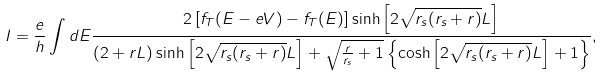<formula> <loc_0><loc_0><loc_500><loc_500>I = \frac { e } { h } \int d E \frac { 2 \left [ f _ { T } ( E - e V ) - f _ { T } ( E ) \right ] \sinh { \left [ 2 \sqrt { r _ { s } ( r _ { s } + r ) } L \right ] } } { ( 2 + r L ) \sinh { \left [ 2 \sqrt { r _ { s } ( r _ { s } + r ) } L \right ] } + \sqrt { \frac { r } { r _ { s } } + 1 } \left \{ \cosh { \left [ 2 \sqrt { r _ { s } ( r _ { s } + r ) } L \right ] } + 1 \right \} } ,</formula> 